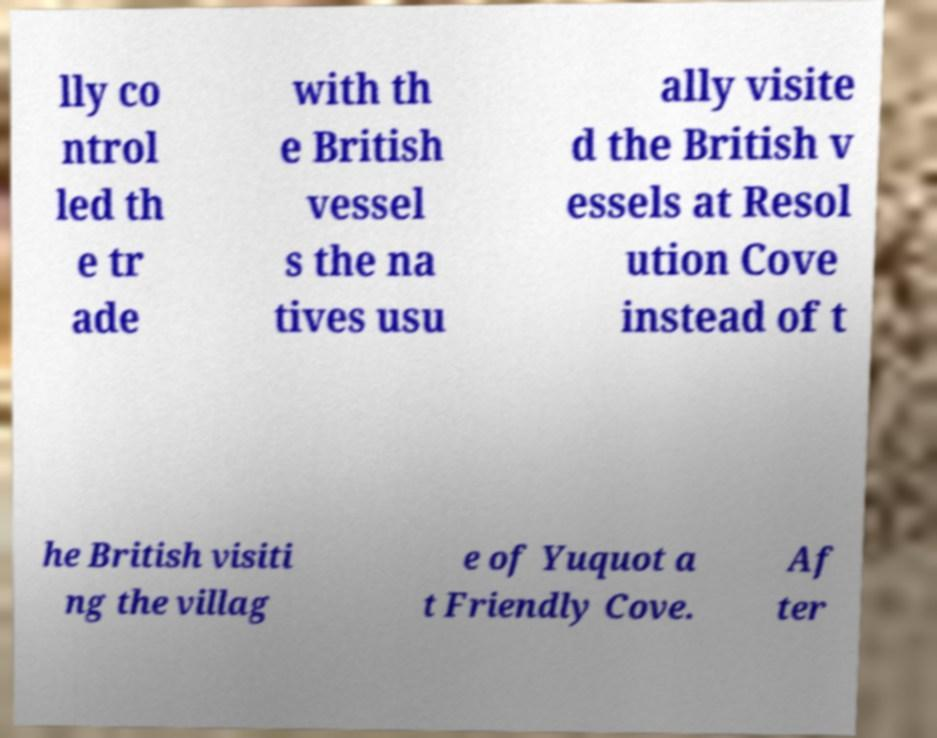For documentation purposes, I need the text within this image transcribed. Could you provide that? lly co ntrol led th e tr ade with th e British vessel s the na tives usu ally visite d the British v essels at Resol ution Cove instead of t he British visiti ng the villag e of Yuquot a t Friendly Cove. Af ter 